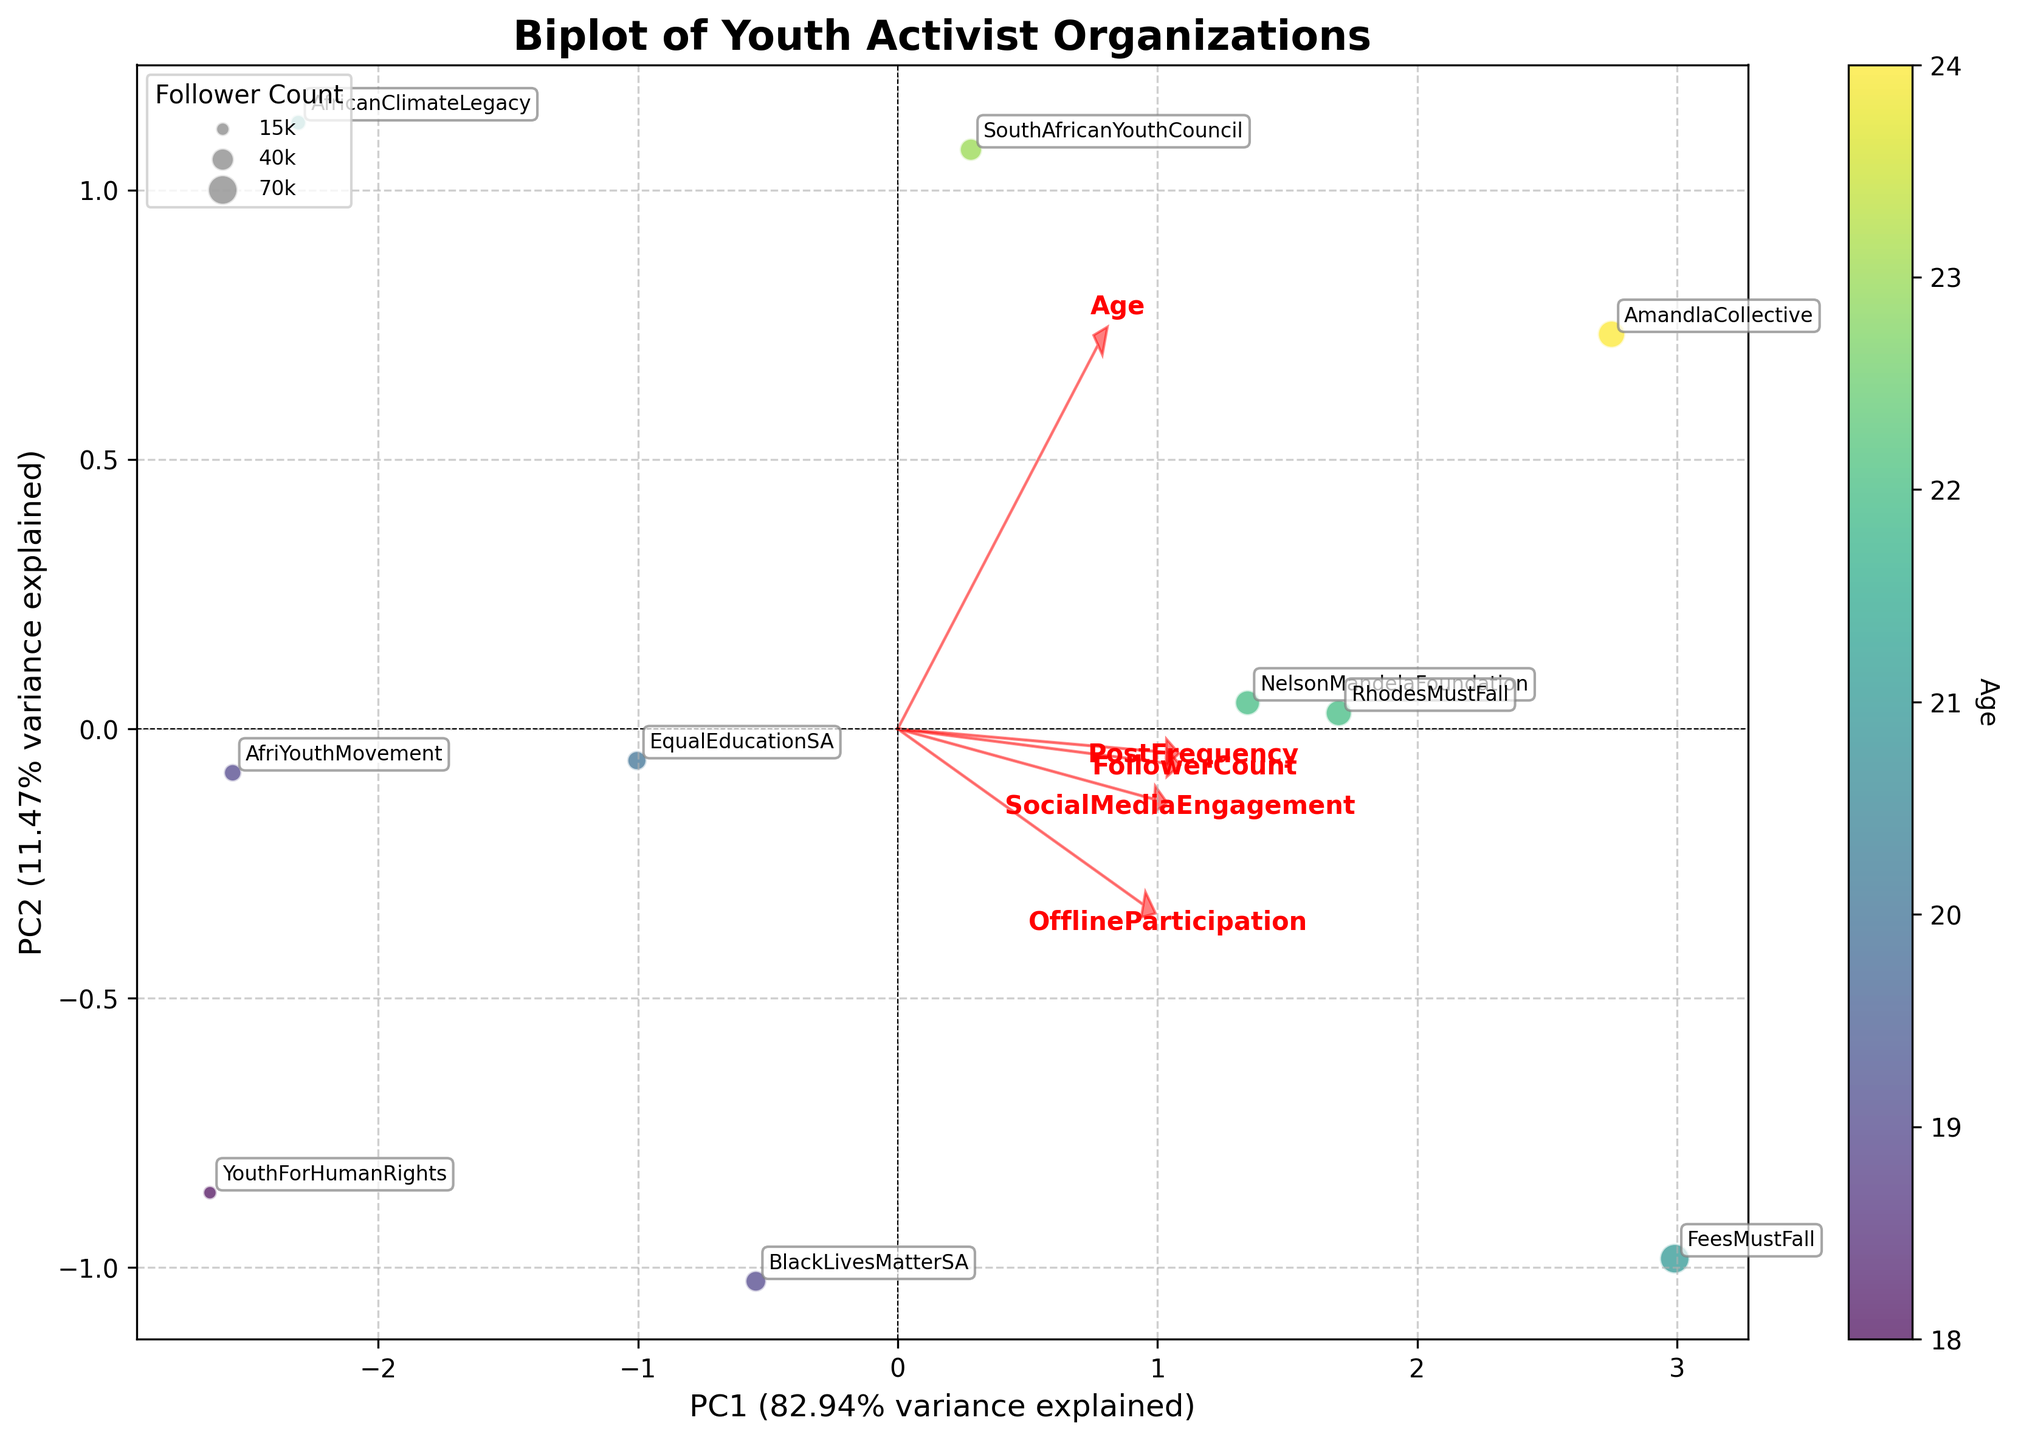What is the title of the figure? The title is usually found at the top of the figure and summarises the main focus of the visualisation. In this case, it reads "Biplot of Youth Activist Organizations".
Answer: Biplot of Youth Activist Organizations Which organization has the highest OfflineParticipation score? OfflineParticipation scores can be identified by looking at the data points and their annotations in the biplot. Points further along the arrow for OfflineParticipation have higher scores. The annotation closest to the tip of this arrow is "FeesMustFall" with a score of 98 in the data provided.
Answer: FeesMustFall How many principal components are plotted in the biplot? Principal components are the axes in a biplot. In this plot, there are two principal components (PC1 and PC2) as indicated by the axes labels.
Answer: 2 Which variable's loading vector points furthest to the right? By observing the loadings for each variable, the vector pointing furthest to the right is the one with the largest positive value on the x-axis. In this case, that's "FollowerCount".
Answer: FollowerCount What color represents the youngest activists? The colorbar on the side of the plot represents age. Lighter colors (yellow) represent younger ages, as inferred by the viridis color scale used.
Answer: Yellow Which organizations are most similar in terms of their principal components? In a biplot, organizations that are clustered together are most similar. "RhodesMustFall" and "NelsonMandelaFoundation" are very close to each other in the plot, indicating they have similar principal component scores.
Answer: RhodesMustFall and NelsonMandelaFoundation Which organization has the smallest bubble size? Bubble sizes in this plot correlate with follower counts. The smallest bubble represents the organization with the smallest follower count. According to the data, "YouthForHumanRights" has the lowest follower count of 15000.
Answer: YouthForHumanRights What do the arrows represent in the biplot? The arrows in a biplot represent the loading vectors for each variable. They show the direction and importance of each variable to the principal components. Their length indicates the strength of the correlation with the principal components.
Answer: Loading vectors for variables 